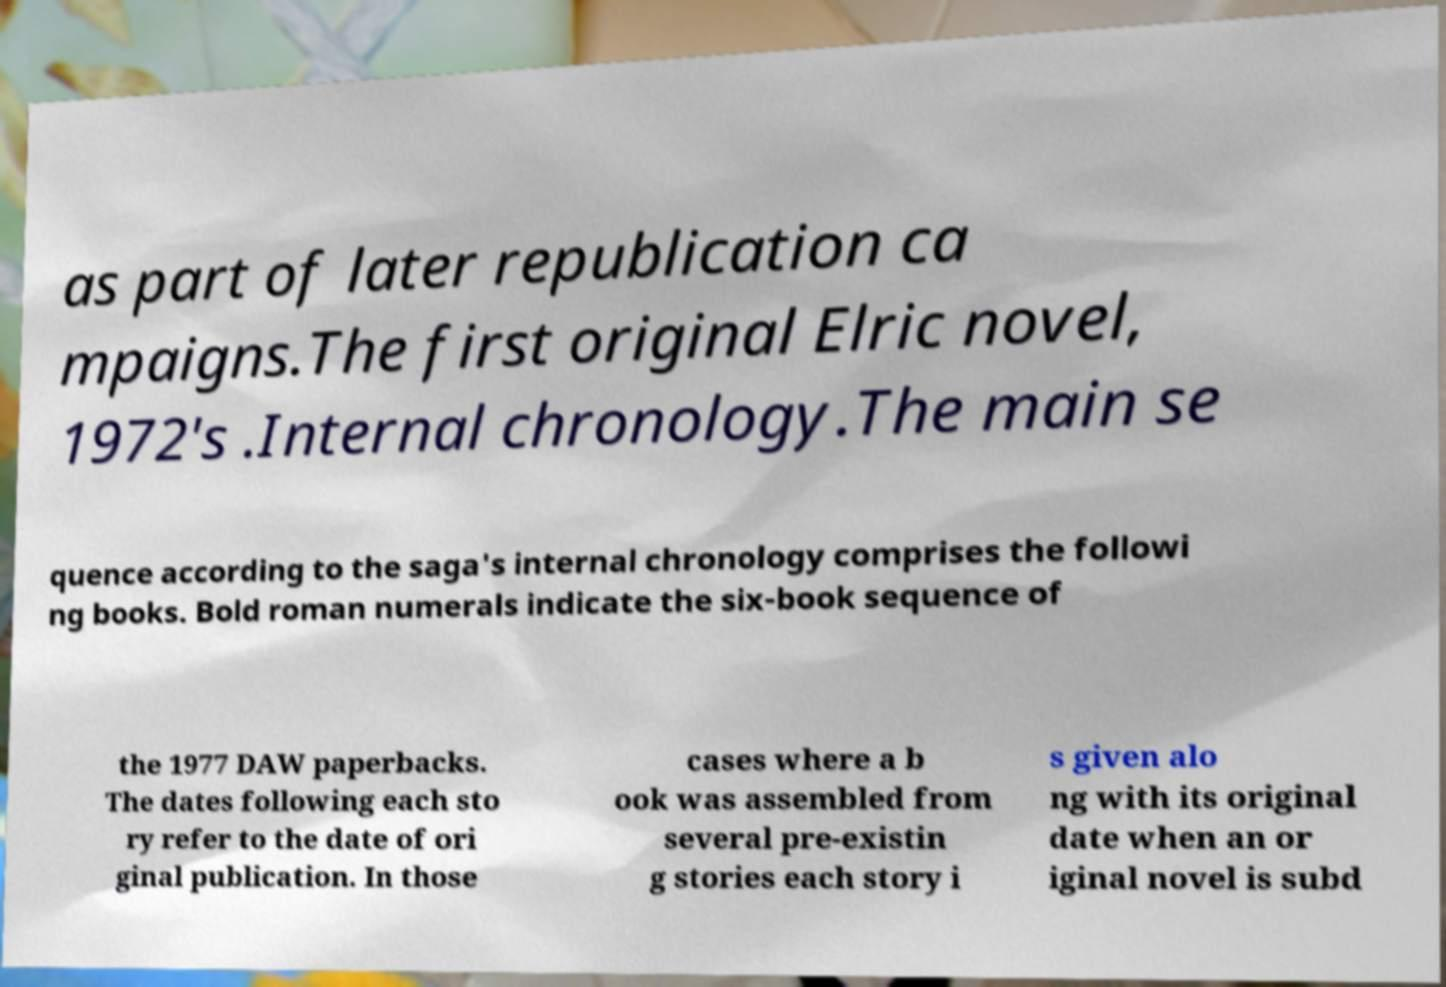What messages or text are displayed in this image? I need them in a readable, typed format. as part of later republication ca mpaigns.The first original Elric novel, 1972's .Internal chronology.The main se quence according to the saga's internal chronology comprises the followi ng books. Bold roman numerals indicate the six-book sequence of the 1977 DAW paperbacks. The dates following each sto ry refer to the date of ori ginal publication. In those cases where a b ook was assembled from several pre-existin g stories each story i s given alo ng with its original date when an or iginal novel is subd 